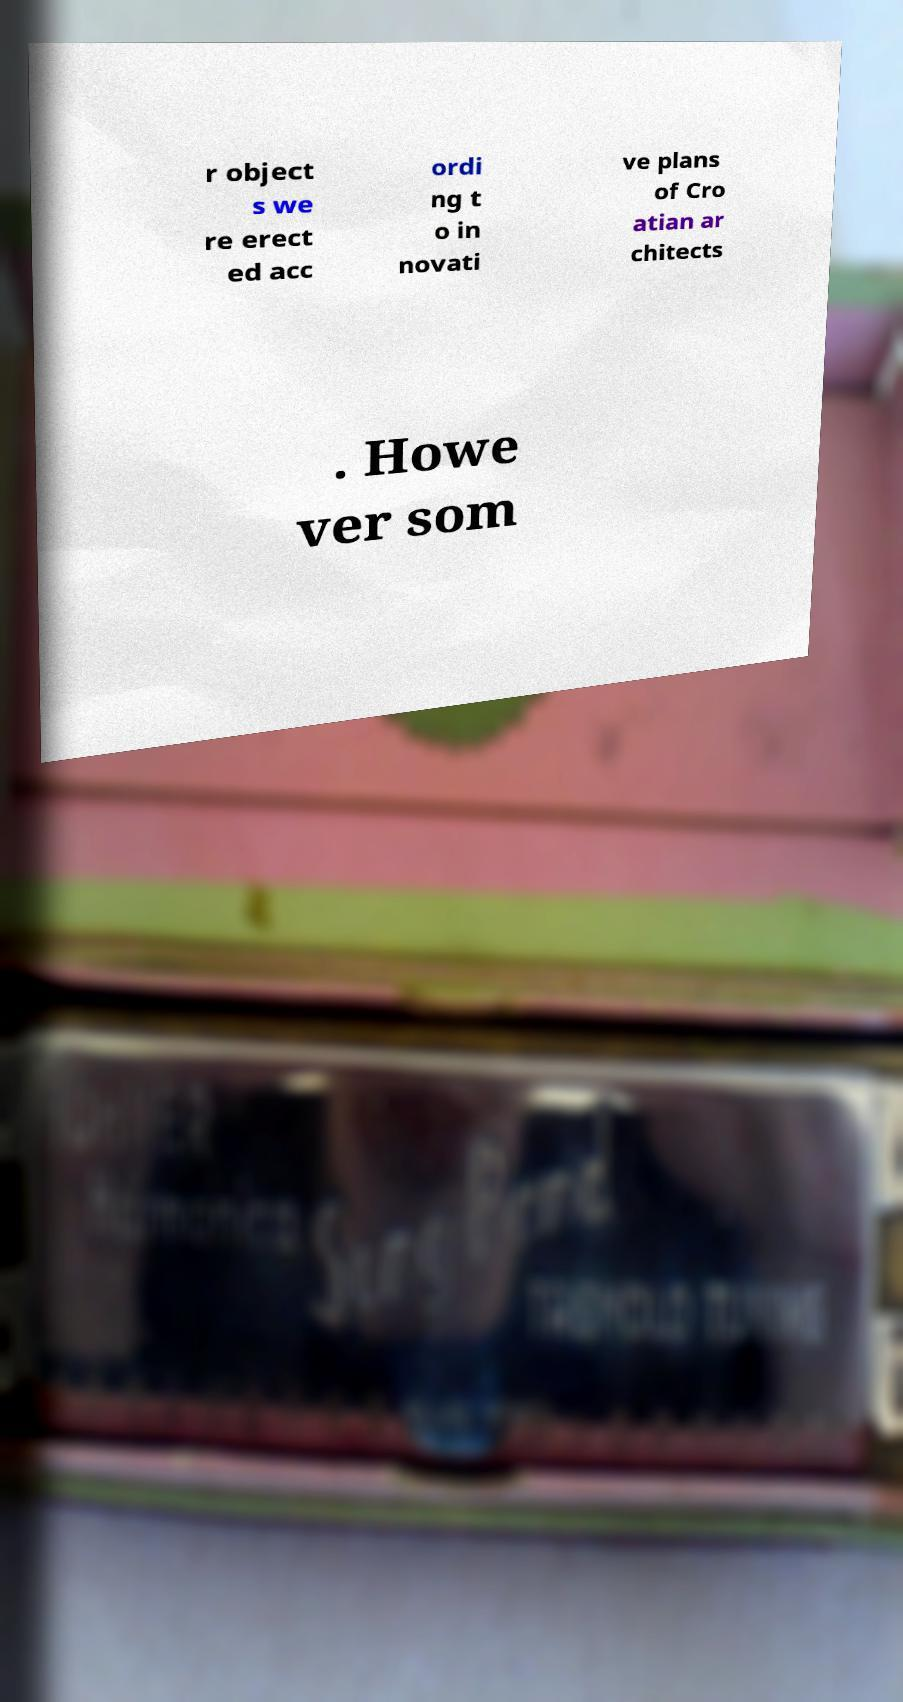For documentation purposes, I need the text within this image transcribed. Could you provide that? r object s we re erect ed acc ordi ng t o in novati ve plans of Cro atian ar chitects . Howe ver som 